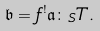<formula> <loc_0><loc_0><loc_500><loc_500>\mathfrak { b } = f ^ { ! } \mathfrak { a } \colon _ { S } T .</formula> 